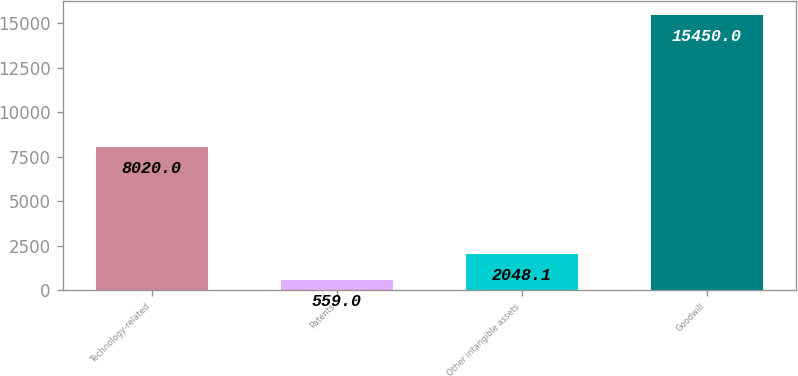Convert chart to OTSL. <chart><loc_0><loc_0><loc_500><loc_500><bar_chart><fcel>Technology-related<fcel>Patents<fcel>Other intangible assets<fcel>Goodwill<nl><fcel>8020<fcel>559<fcel>2048.1<fcel>15450<nl></chart> 